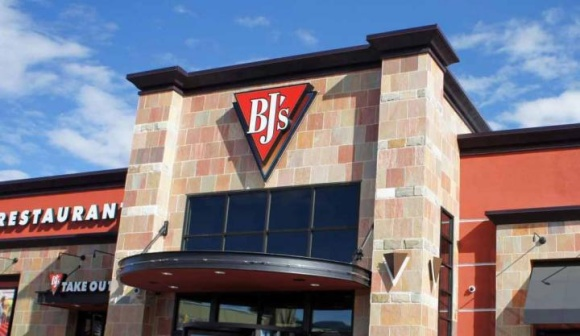What are the key elements in this picture? The image prominently features the facade of BJ's Restaurant and Brewhouse. Constructed with brick and adorned with a conspicuous red and black triangular logo displaying 'BJ's' in white, it catches the eye. Above the main entrance, there's a curved awning, which not only adds to the aesthetic but also invites customers inside. Signage on either side of the door distinguishes the services offered, with 'Restaurant' on the left and 'Take Out' on the right. The scene, set under a bright blue sky with light clouds, suggests a welcoming and bustling venue, likely popular for its variety of craft beers and an extensive menu that includes pizzas, burgers, and more. 